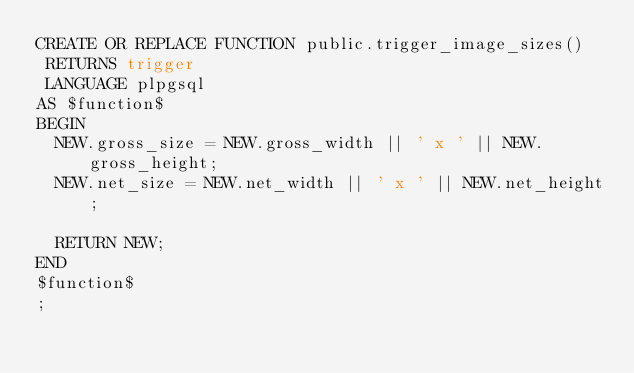Convert code to text. <code><loc_0><loc_0><loc_500><loc_500><_SQL_>CREATE OR REPLACE FUNCTION public.trigger_image_sizes()
 RETURNS trigger
 LANGUAGE plpgsql
AS $function$
BEGIN
  NEW.gross_size = NEW.gross_width || ' x ' || NEW.gross_height;
  NEW.net_size = NEW.net_width || ' x ' || NEW.net_height;
  
  RETURN NEW;
END
$function$
;
</code> 